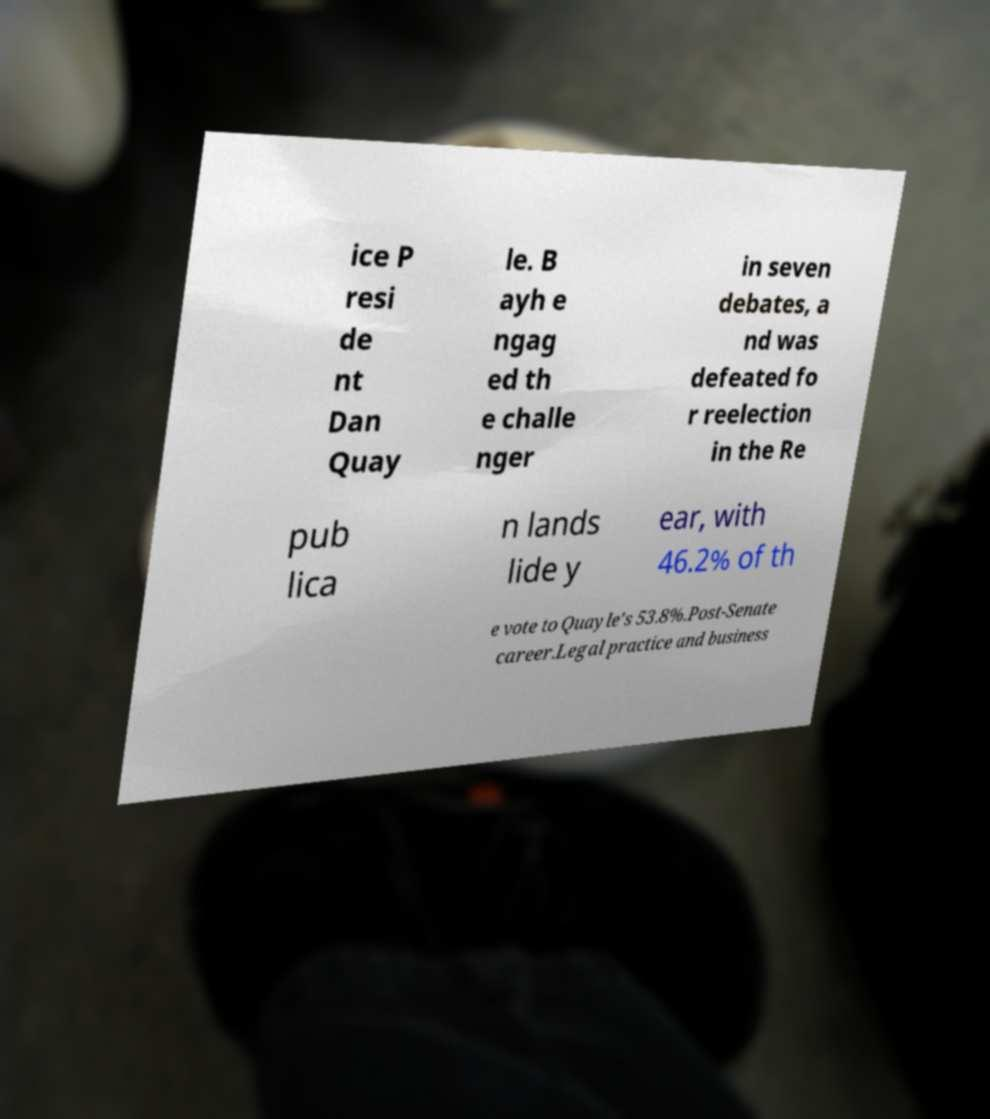What messages or text are displayed in this image? I need them in a readable, typed format. ice P resi de nt Dan Quay le. B ayh e ngag ed th e challe nger in seven debates, a nd was defeated fo r reelection in the Re pub lica n lands lide y ear, with 46.2% of th e vote to Quayle's 53.8%.Post-Senate career.Legal practice and business 